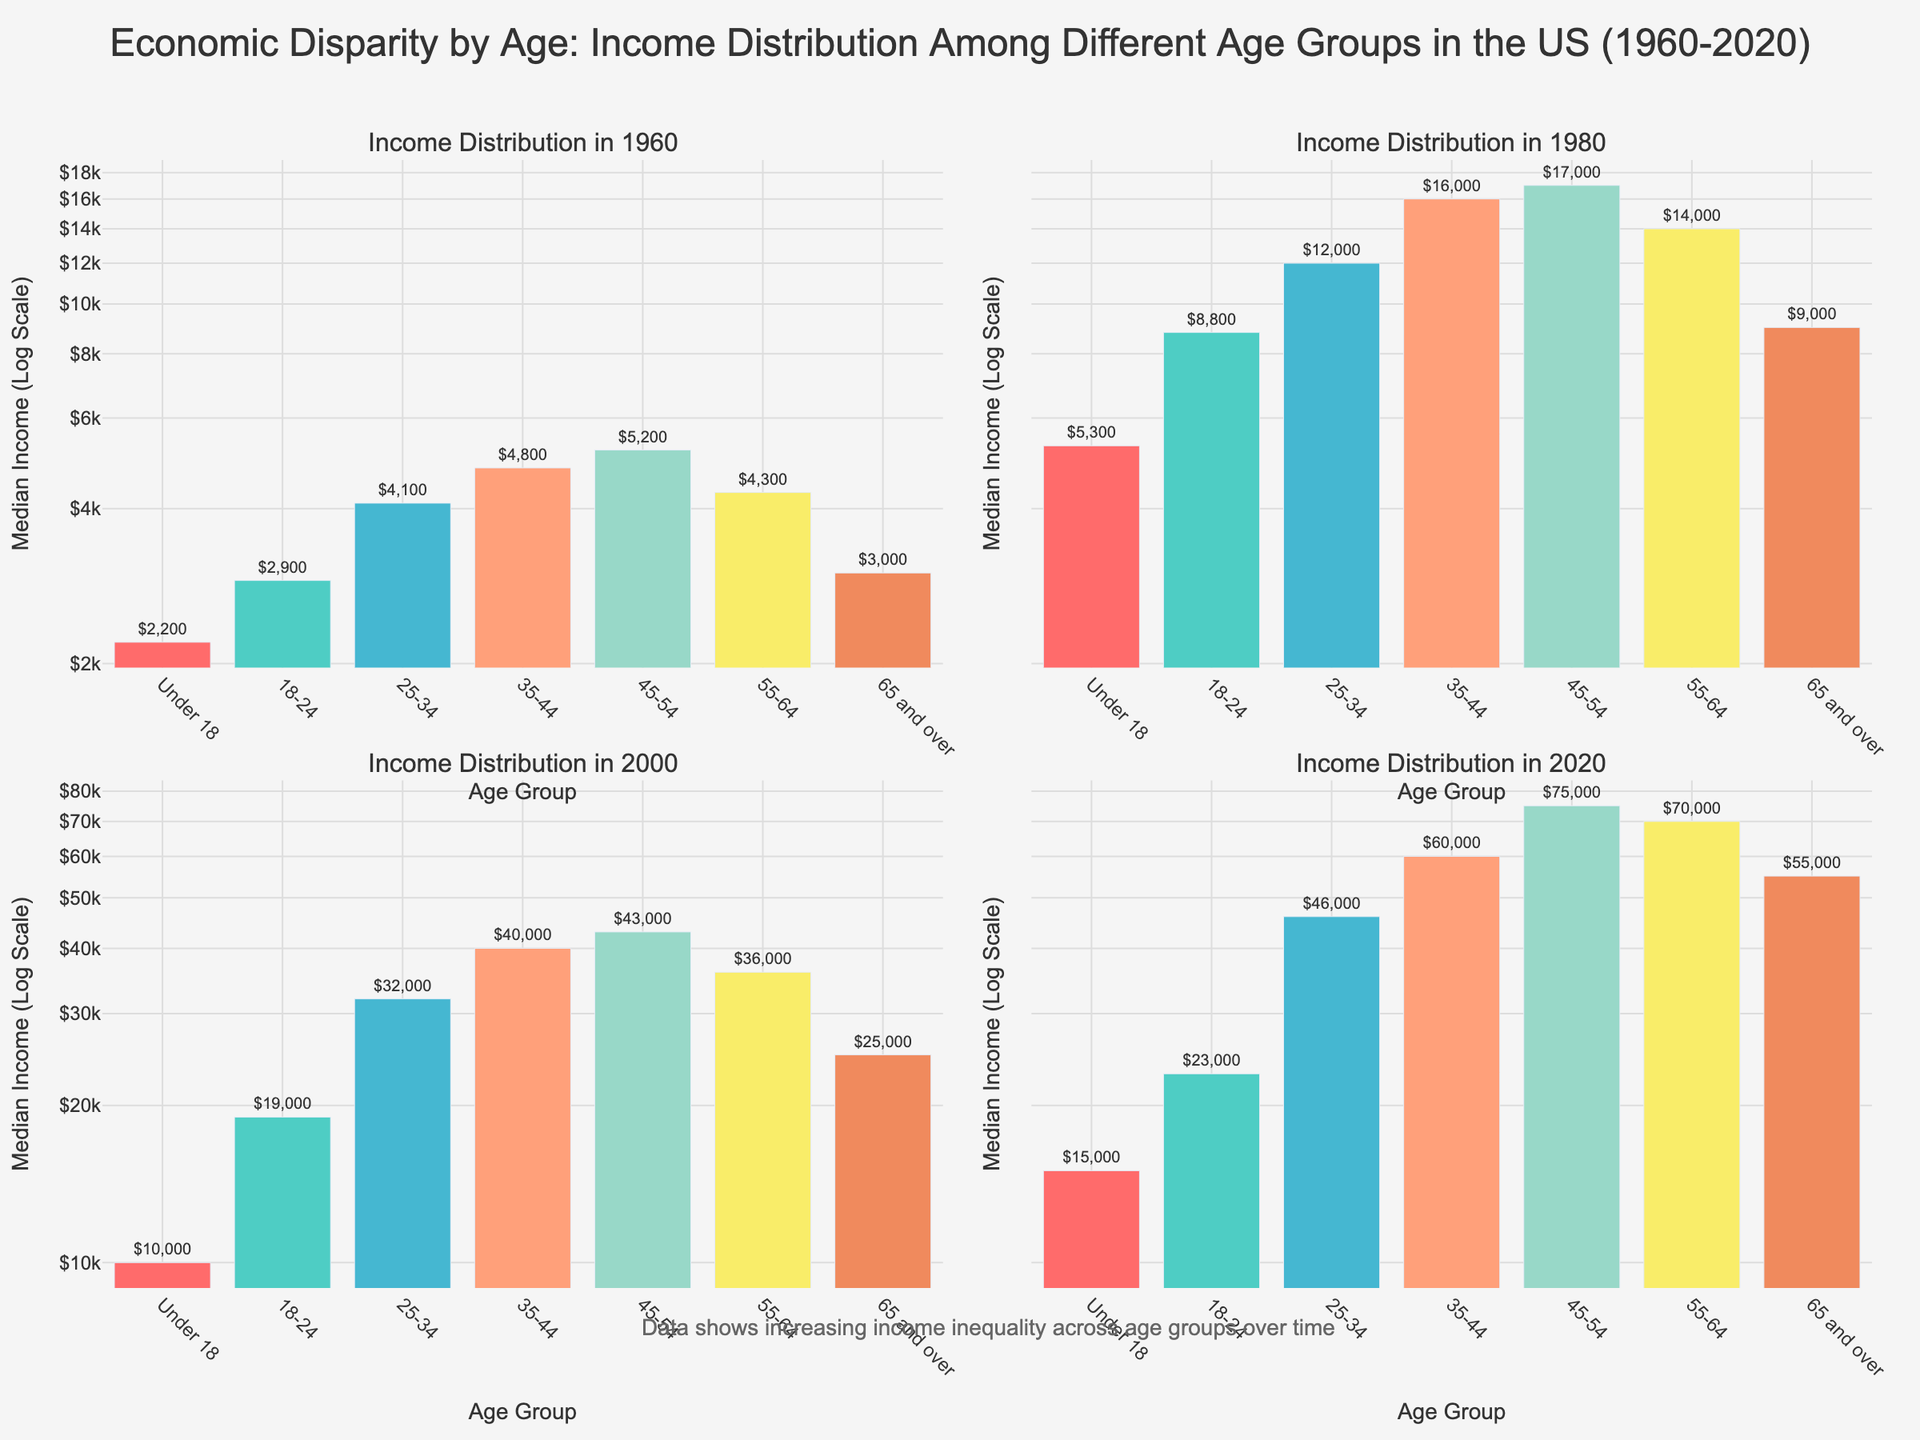What is the title of the figure? The title is clearly mentioned at the top of the figure. The title reads "Economic Disparity by Age: Income Distribution Among Different Age Groups in the US (1960-2020)"
Answer: Economic Disparity by Age: Income Distribution Among Different Age Groups in the US (1960-2020) Which age group had the lowest median income in 1980? By looking at the bar for 1980 and comparing the heights of the bars, the Under 18 age group has the shortest bar, indicating they have the lowest median income
Answer: Under 18 What is the median income for the 25-34 age group in 2020? By observing the height of the bar for the 25-34 age group in the 2020 subplot, the text on or near the bar indicates the median income
Answer: $46,000 How did the median income for the 65 and over age group change from 1960 to 2020? Observing the height and labels of the bars for the 65 and over age group in 1960 and 2020, we note they increased from $3,000 in 1960 to $55,000 in 2020
Answer: It increased from $3,000 to $55,000 What is the difference in median income between the 45-54 and 55-64 age groups in 2020? Subtract the median income value for the 55-64 age group from the 45-54 age group in 2020. From 2020, these bars indicate they are $75,000 and $70,000 respectively. So, $75,000 - $70,000
Answer: $5,000 Which year shows the highest overall median income values across all age groups? By comparing the heights of the bars across all the subplots, 2020 consistently shows the tallest bars for all age groups
Answer: 2020 Did the median income for the Under 18 age group increase or decrease between 2000 and 2020? By comparing the height of the bars for the Under 18 age group in the 2000 and 2020 subplots, notice the bar height increased from $10,000 to $15,000
Answer: Increase Which age group had the most significant increase in median income from 1960 to 2020? Calculate the difference in median incomes for each age group between 1960 and 2020, and compare these differences. The 45-54 age group increased from $5,200 in 1960 to $75,000 in 2020. This is the most significant change
Answer: 45-54 Is there any age group whose median income consistently decreased over the years? By observing the trends of the bars across the four subplots for each age group, notice that all age groups show a general trend of increasing median income
Answer: No What is common about the y-axis scale in all the subplots? Observing the y-axes of all four subplots, they have a log scale instead of a linear scale
Answer: Log scale 